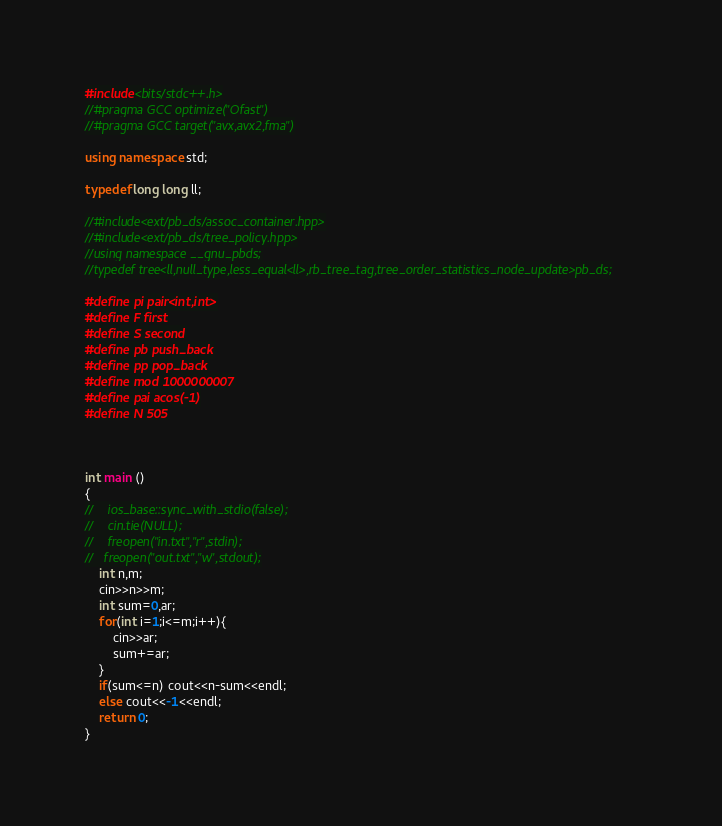<code> <loc_0><loc_0><loc_500><loc_500><_C++_>#include<bits/stdc++.h>
//#pragma GCC optimize("Ofast")
//#pragma GCC target("avx,avx2,fma")

using namespace std;

typedef long long ll;

//#include<ext/pb_ds/assoc_container.hpp>
//#include<ext/pb_ds/tree_policy.hpp>
//using namespace __gnu_pbds;
//typedef tree<ll,null_type,less_equal<ll>,rb_tree_tag,tree_order_statistics_node_update>pb_ds;

#define pi pair<int,int>
#define F first
#define S second
#define pb push_back
#define pp pop_back
#define mod 1000000007
#define pai acos(-1)
#define N 505



int main ()
{
//    ios_base::sync_with_stdio(false);
//    cin.tie(NULL);
//    freopen("in.txt","r",stdin);
//   freopen("out.txt","w",stdout);
    int n,m;
    cin>>n>>m;
    int sum=0,ar;
    for(int i=1;i<=m;i++){
        cin>>ar;
        sum+=ar;
    }
    if(sum<=n) cout<<n-sum<<endl;
    else cout<<-1<<endl;
    return 0;
}

</code> 